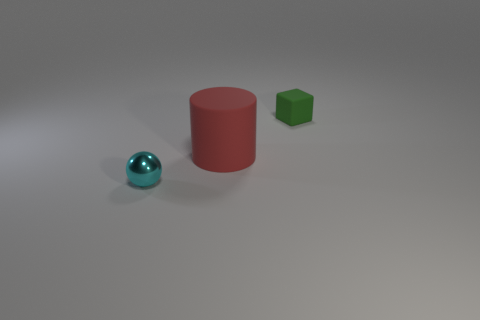Can you comment on the colors present in the image? Certainly, the image exhibits a limited color palette consisting of a red, green, and blue object. The red and green objects have a solid, matte finish, while the blue object has a vibrant, reflective surface that catches the light. The background and floor are neutral gray, which accentuates the colors of the objects. 